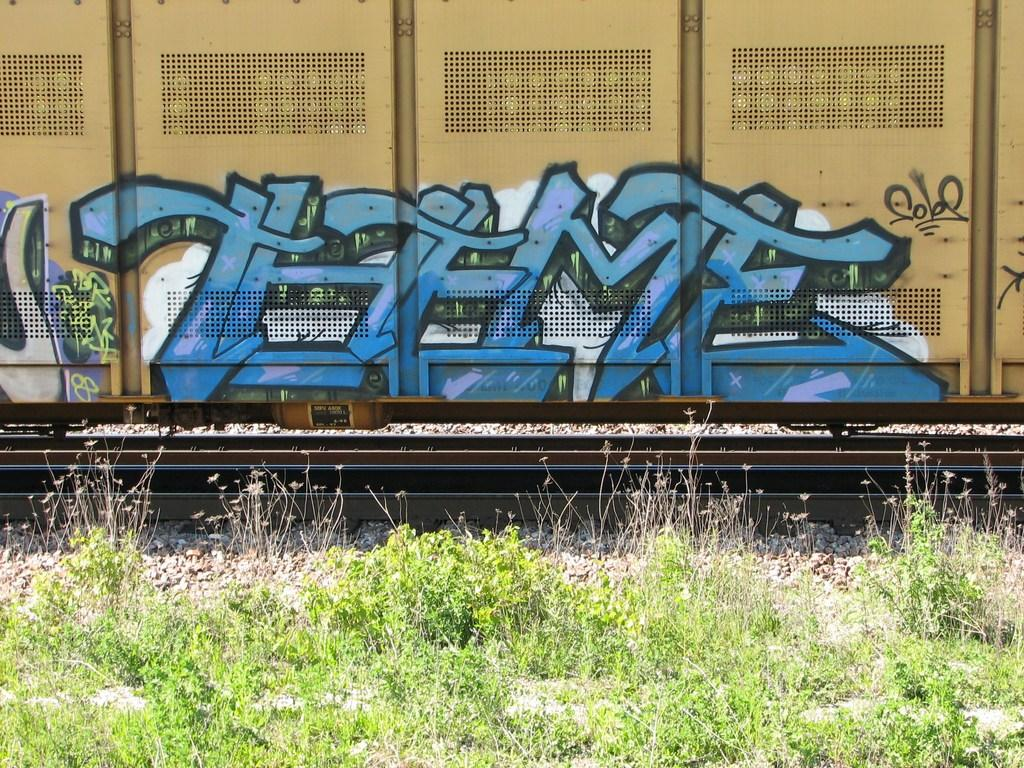<image>
Summarize the visual content of the image. A train is going by a weeded area and there is graffiti on the side that says THEME. 